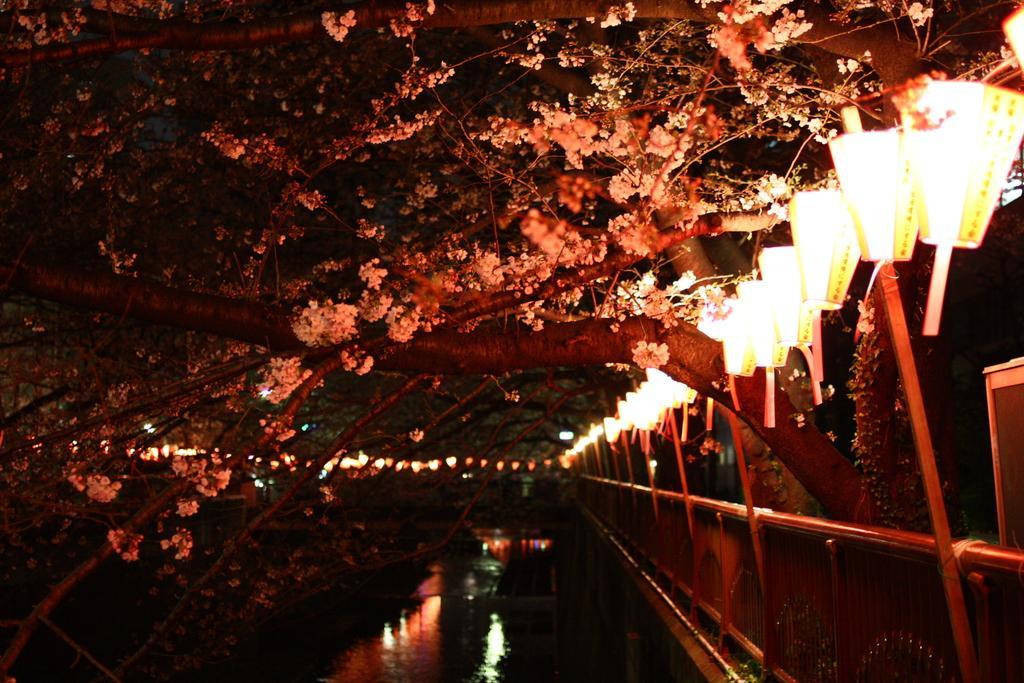How would you summarize this image in a sentence or two? This image is taken outdoors. At the top of the image there are a few trees with leaves, stems, branches and flowers. In the background there are a few lights. On the right side of the image there is a fence. There are many lamps. In the middle of the image there is a pool with water. 